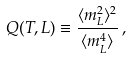Convert formula to latex. <formula><loc_0><loc_0><loc_500><loc_500>Q ( T , L ) \equiv \frac { \langle m _ { L } ^ { 2 } \rangle ^ { 2 } } { \langle m _ { L } ^ { 4 } \rangle } \, ,</formula> 